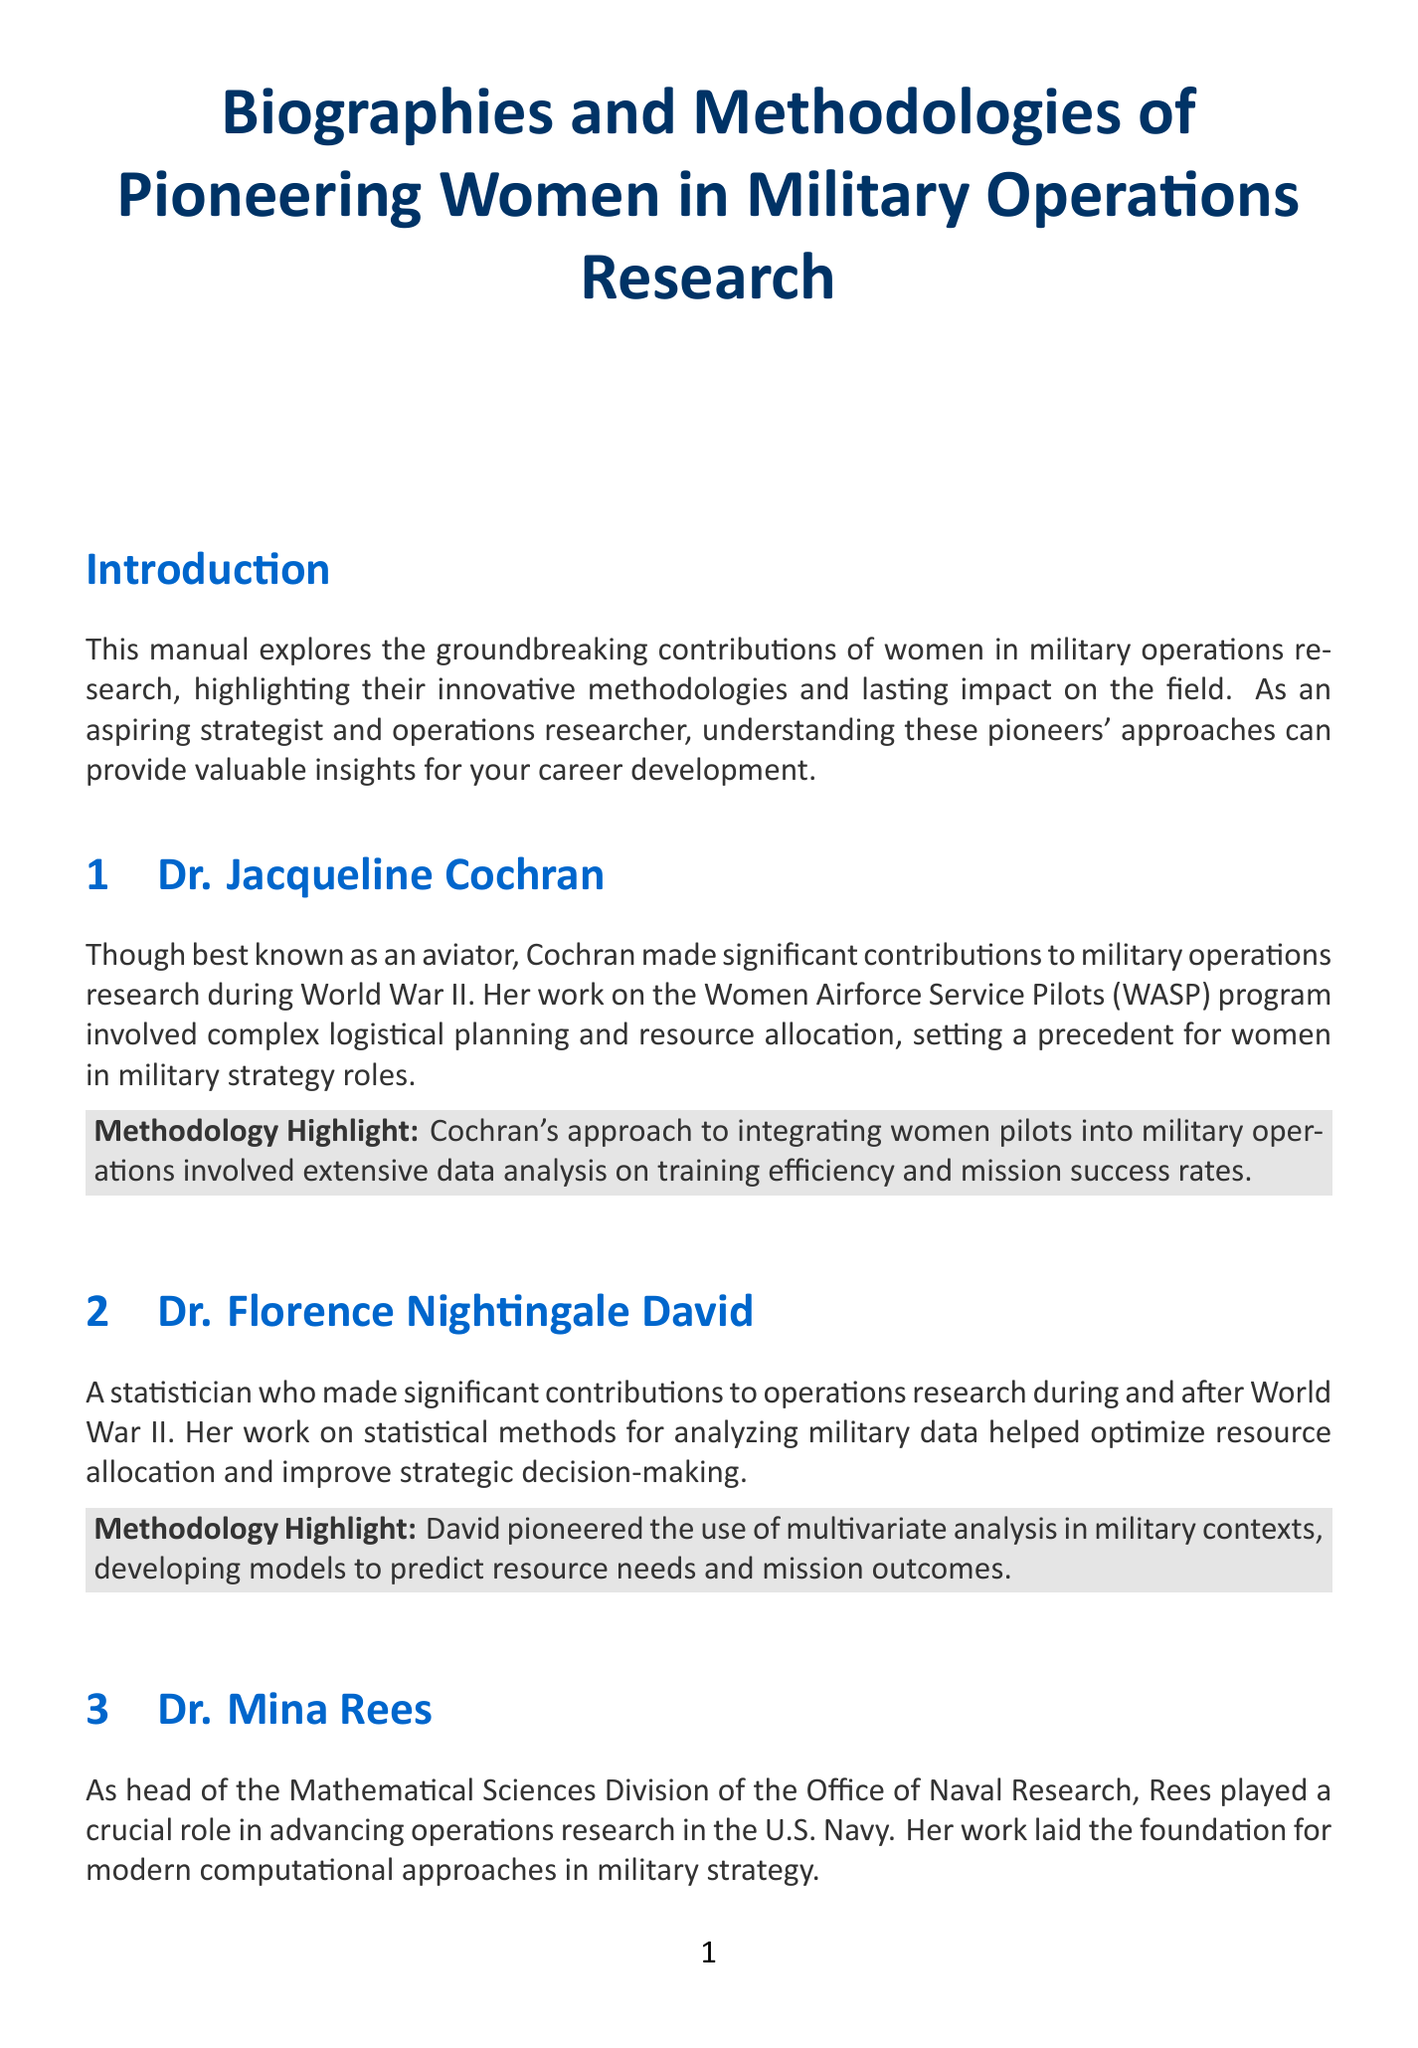What is the title of the manual? The title is explicitly stated at the beginning of the document, detailing the subject matter it covers.
Answer: Biographies and Methodologies of Pioneering Women in Military Operations Research Who made significant contributions to military operations research during World War II? This is found in the biography section highlighting the work of specific individuals, particularly during the Second World War.
Answer: Dr. Jacqueline Cochran What methodology did Dr. Florence Nightingale David pioneer? The document outlines her contributions specifically in the context of military data analysis methods.
Answer: Multivariate analysis In which division did Dr. Mina Rees serve as head? The document mentions her leadership role in a specific division related to naval operations research.
Answer: Mathematical Sciences Division What was one of the focuses of Dr. Julie Payette's research projects? Her work is summarized within her section, emphasizing a particular area of military technology.
Answer: Communication systems How did Dr. Howardine Hoffman influence U.S. policy? This question requires an understanding of her contributions and the broader implications of her work outlined in her biography.
Answer: Nuclear deterrence strategies What is one key takeaway highlighted in the document? The manual concludes with a list of important points to remember, summarizing broader lessons learned.
Answer: Interdisciplinary collaboration is crucial in solving complex military operational problems Which woman is recognized for contributions to cryptography? This asks for identification based on unique contributions mentioned in the document regarding cybersecurity.
Answer: Dr. Cynthia Dwork 